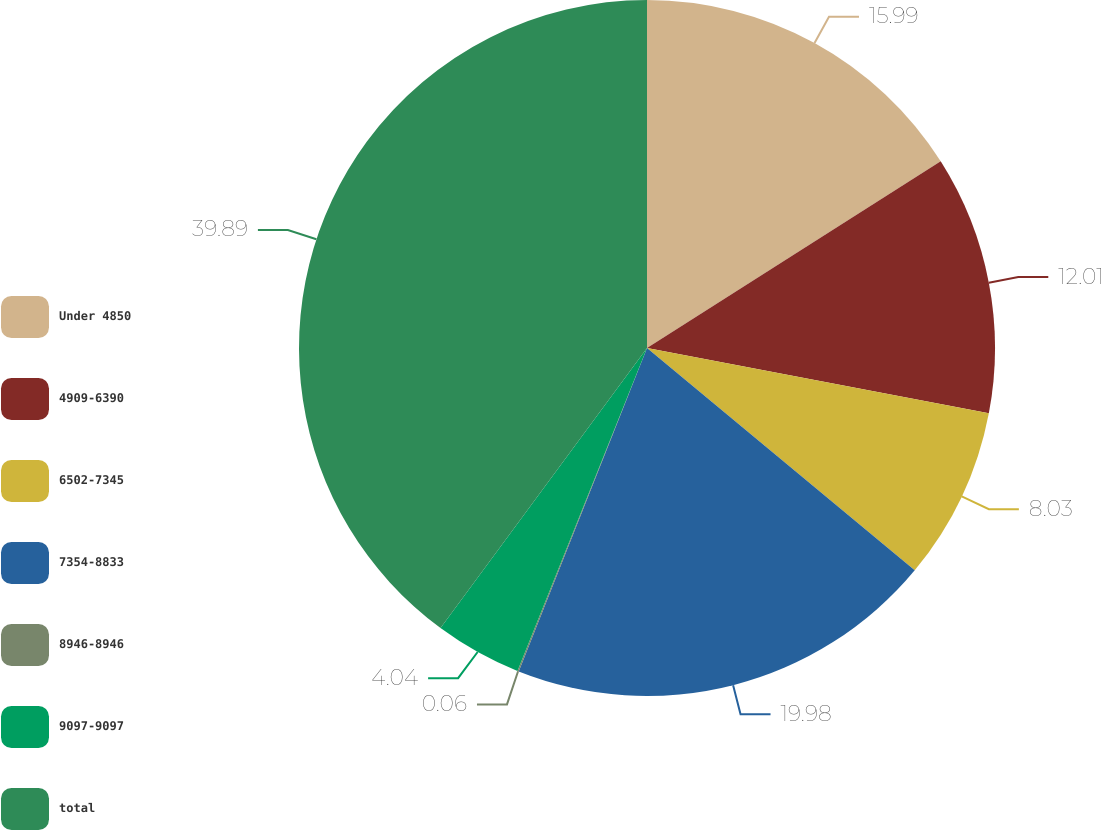<chart> <loc_0><loc_0><loc_500><loc_500><pie_chart><fcel>Under 4850<fcel>4909-6390<fcel>6502-7345<fcel>7354-8833<fcel>8946-8946<fcel>9097-9097<fcel>total<nl><fcel>15.99%<fcel>12.01%<fcel>8.03%<fcel>19.98%<fcel>0.06%<fcel>4.04%<fcel>39.89%<nl></chart> 